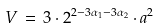<formula> <loc_0><loc_0><loc_500><loc_500>V \, = \, 3 \cdot 2 ^ { 2 - 3 \alpha _ { 1 } - 3 \alpha _ { 2 } } \cdot a ^ { 2 }</formula> 